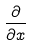<formula> <loc_0><loc_0><loc_500><loc_500>\frac { \partial } { \partial x }</formula> 